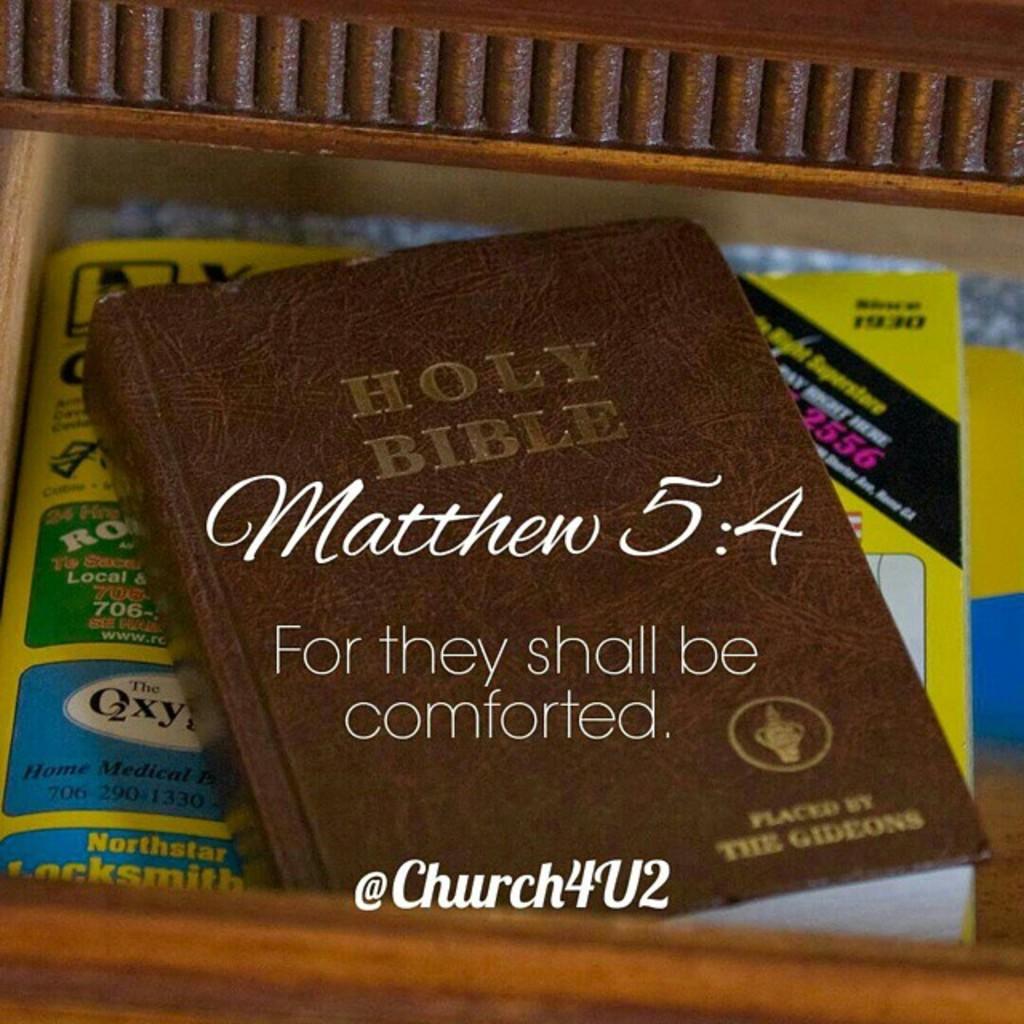Which book is on the table?
Provide a succinct answer. Holy bible. 